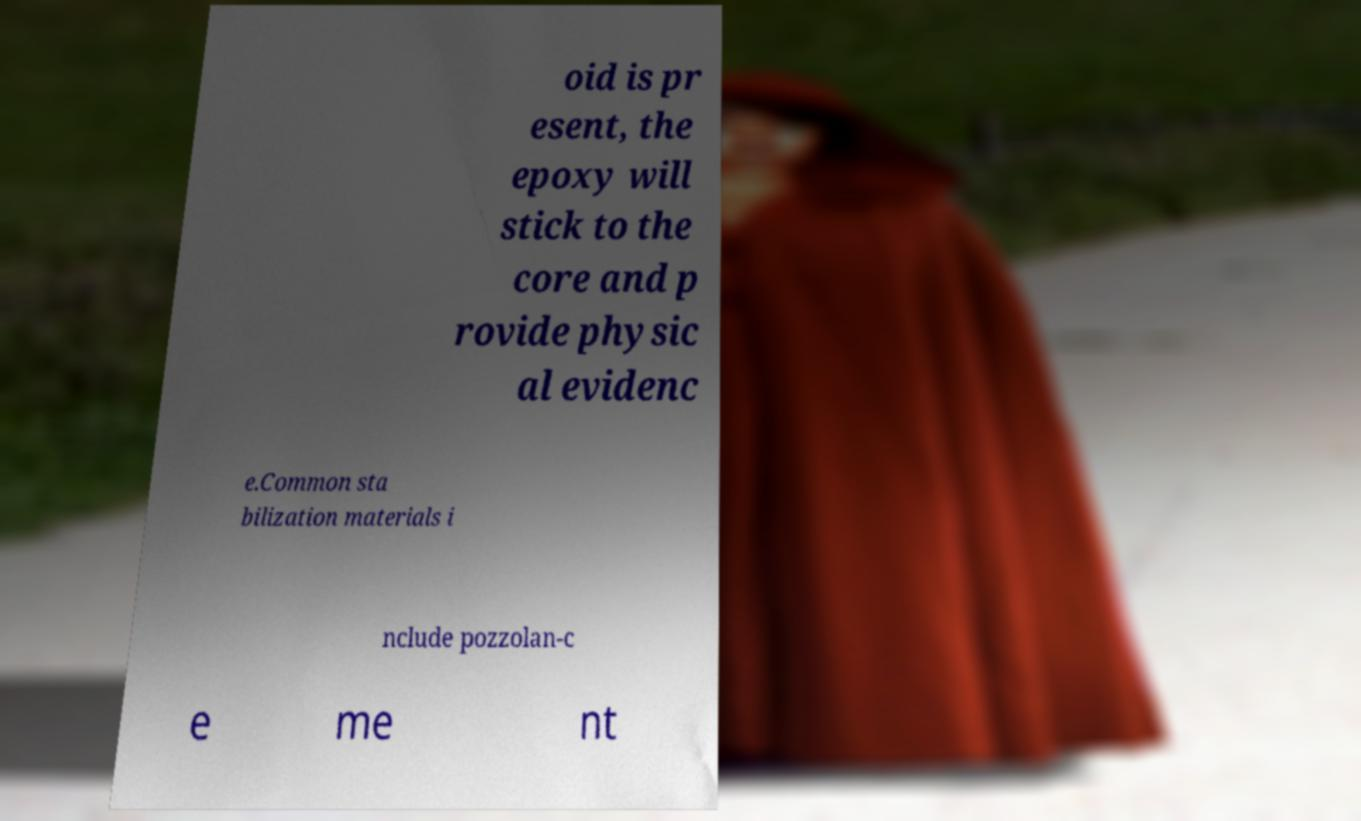Could you extract and type out the text from this image? oid is pr esent, the epoxy will stick to the core and p rovide physic al evidenc e.Common sta bilization materials i nclude pozzolan-c e me nt 